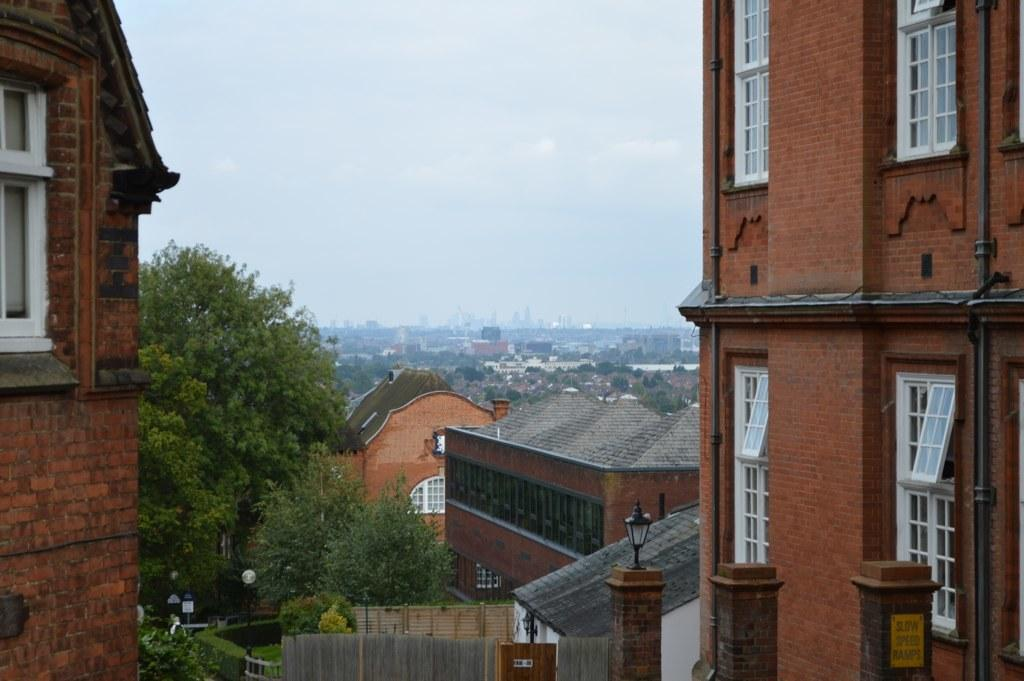What type of structures can be seen in the image? There are buildings in the image. What natural elements are present in the image? There are trees and bushes in the image. What man-made objects can be seen in the image? There are poles, street lights, and pillars in the image. What architectural features are visible on the buildings? There are windows in the image. What part of the natural environment is visible in the image? The sky is visible in the image. How many dogs can be seen jumping over the ornament in the image? There are no dogs or ornaments present in the image. 